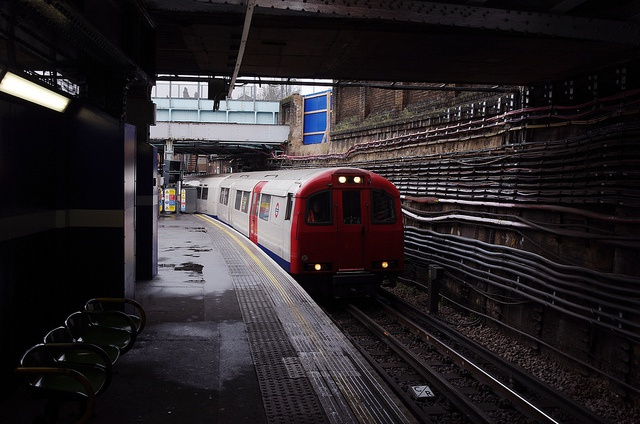Describe the objects in this image and their specific colors. I can see a train in black, darkgray, lightgray, and maroon tones in this image. 